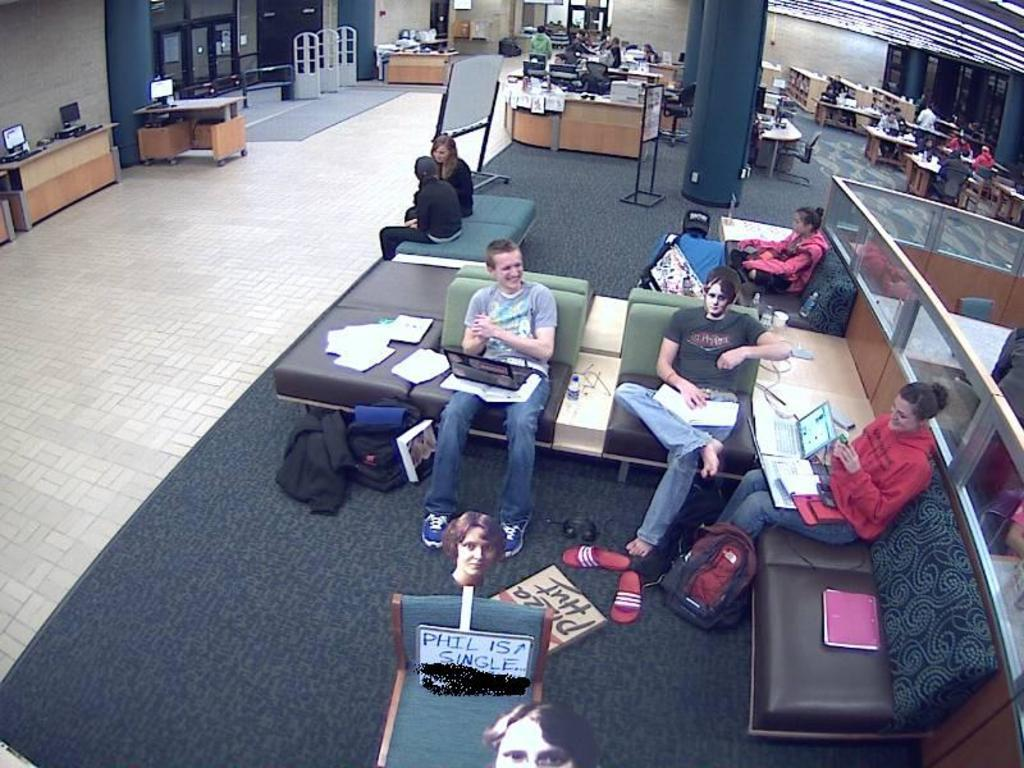What type of room is shown in the image? The image depicts a hall. What furniture is present in the hall? There are chairs, tables, and desks in the hall. What are the people in the image doing? There are people sitting on the chairs. What type of potato dish is being served at the show in the image? There is no potato dish or show present in the image; it depicts a hall with chairs, tables, and desks. What color is the jelly that the people are eating at the event in the image? There is no jelly or event present in the image; it depicts a hall with chairs, tables, and desks. 